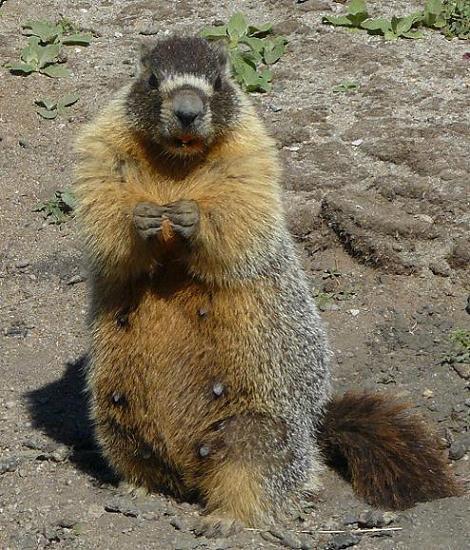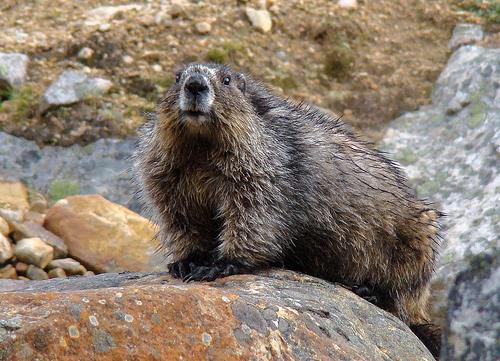The first image is the image on the left, the second image is the image on the right. Analyze the images presented: Is the assertion "One image shows a rodent-type animal standing upright with front paws clasped together." valid? Answer yes or no. Yes. 